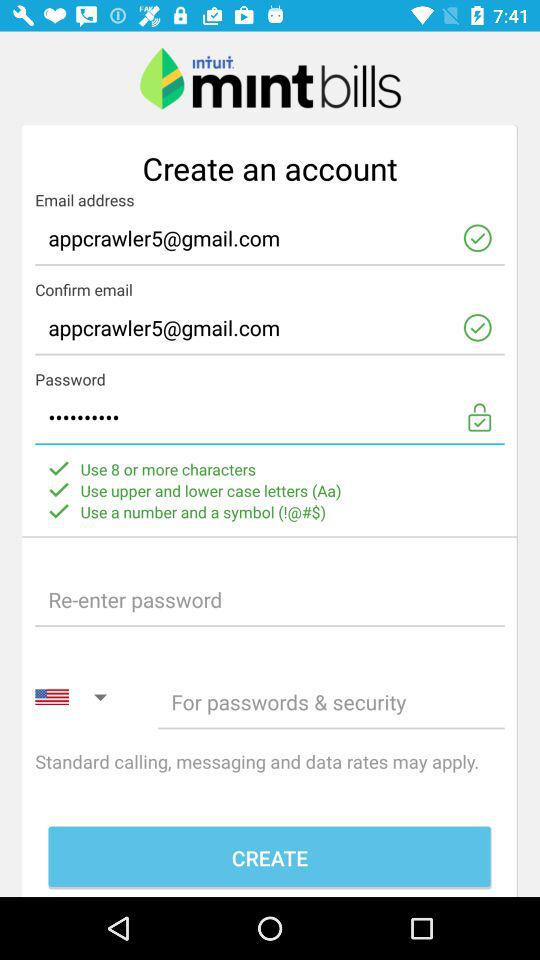What is the application name? The application name is "mint bills". 